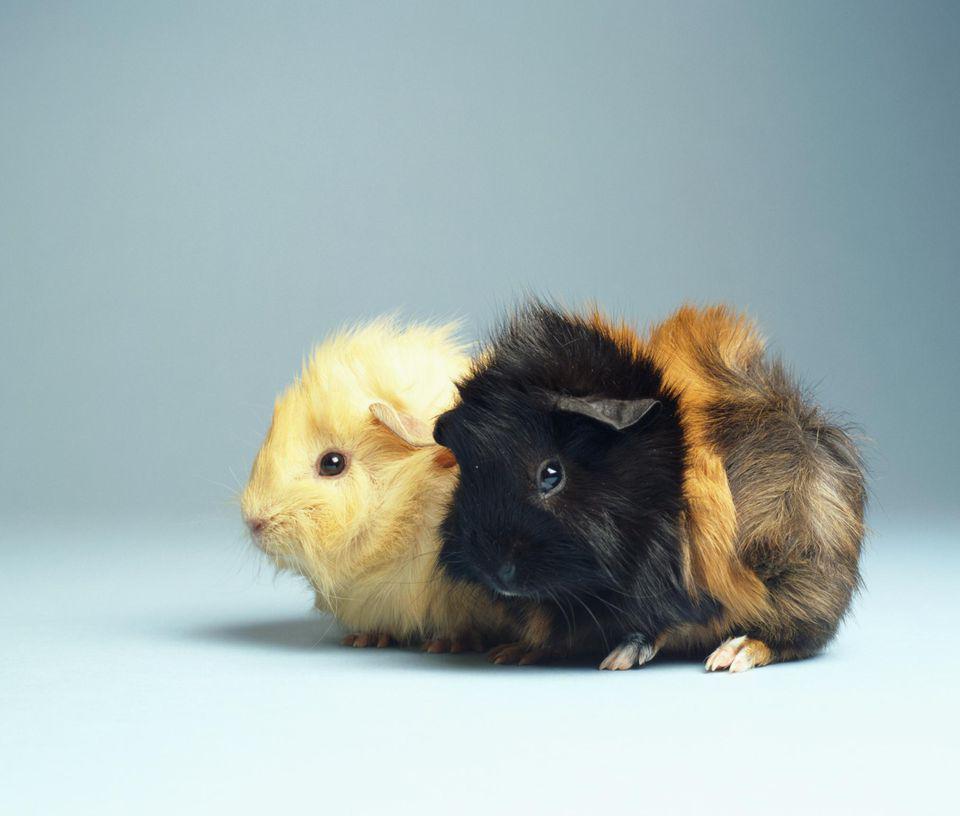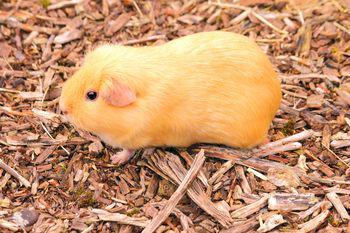The first image is the image on the left, the second image is the image on the right. Examine the images to the left and right. Is the description "There are two guinea pigs in the left image." accurate? Answer yes or no. Yes. 